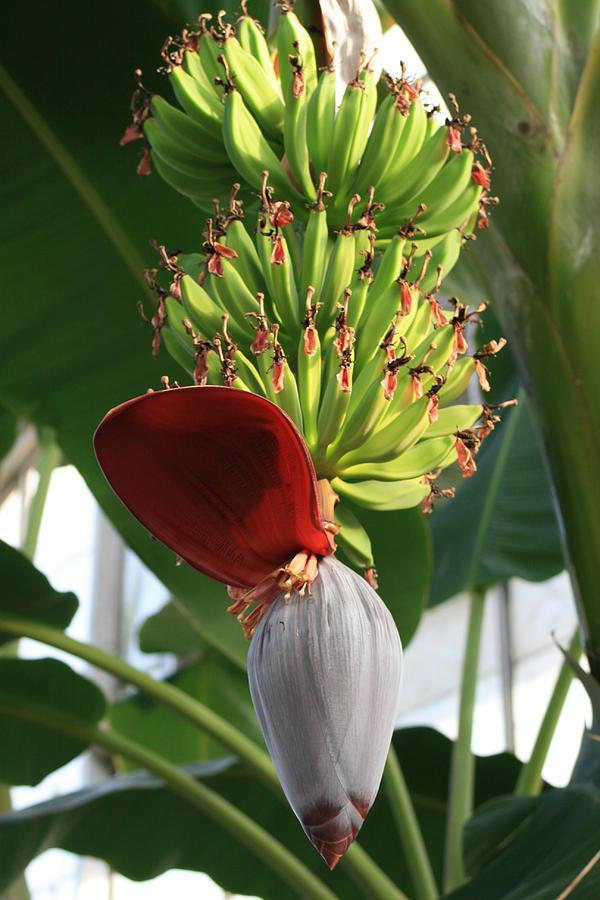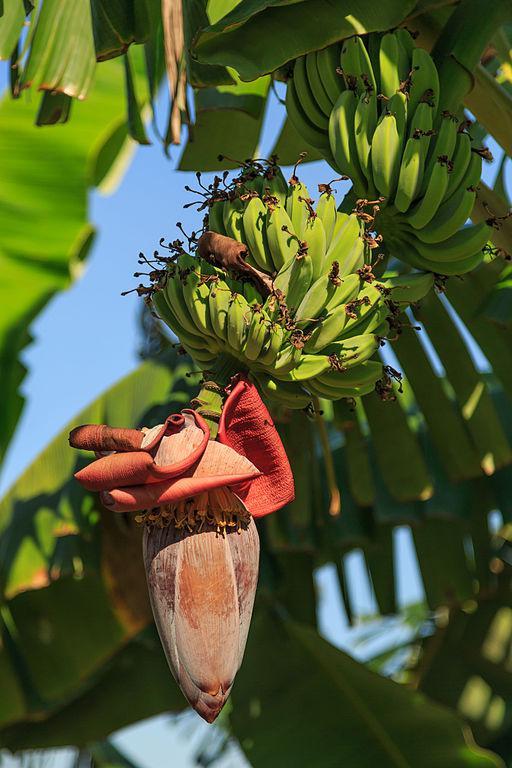The first image is the image on the left, the second image is the image on the right. Given the left and right images, does the statement "There is exactly one flower petal in the left image." hold true? Answer yes or no. Yes. The first image is the image on the left, the second image is the image on the right. For the images displayed, is the sentence "At the bottom of the bananas the flower has at least four petals open." factually correct? Answer yes or no. Yes. 